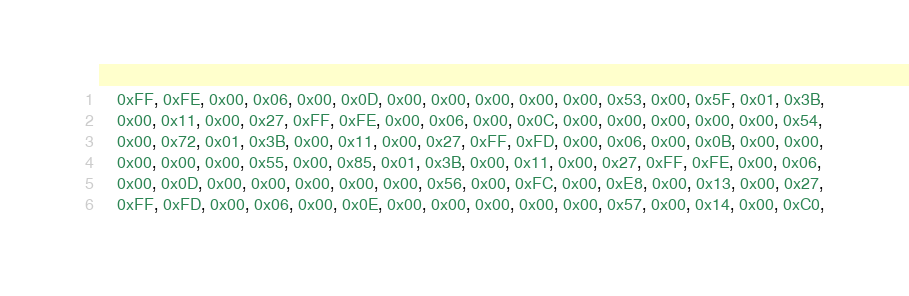<code> <loc_0><loc_0><loc_500><loc_500><_C_>	0xFF, 0xFE, 0x00, 0x06, 0x00, 0x0D, 0x00, 0x00, 0x00, 0x00, 0x00, 0x53, 0x00, 0x5F, 0x01, 0x3B,
	0x00, 0x11, 0x00, 0x27, 0xFF, 0xFE, 0x00, 0x06, 0x00, 0x0C, 0x00, 0x00, 0x00, 0x00, 0x00, 0x54,
	0x00, 0x72, 0x01, 0x3B, 0x00, 0x11, 0x00, 0x27, 0xFF, 0xFD, 0x00, 0x06, 0x00, 0x0B, 0x00, 0x00,
	0x00, 0x00, 0x00, 0x55, 0x00, 0x85, 0x01, 0x3B, 0x00, 0x11, 0x00, 0x27, 0xFF, 0xFE, 0x00, 0x06,
	0x00, 0x0D, 0x00, 0x00, 0x00, 0x00, 0x00, 0x56, 0x00, 0xFC, 0x00, 0xE8, 0x00, 0x13, 0x00, 0x27,
	0xFF, 0xFD, 0x00, 0x06, 0x00, 0x0E, 0x00, 0x00, 0x00, 0x00, 0x00, 0x57, 0x00, 0x14, 0x00, 0xC0,</code> 